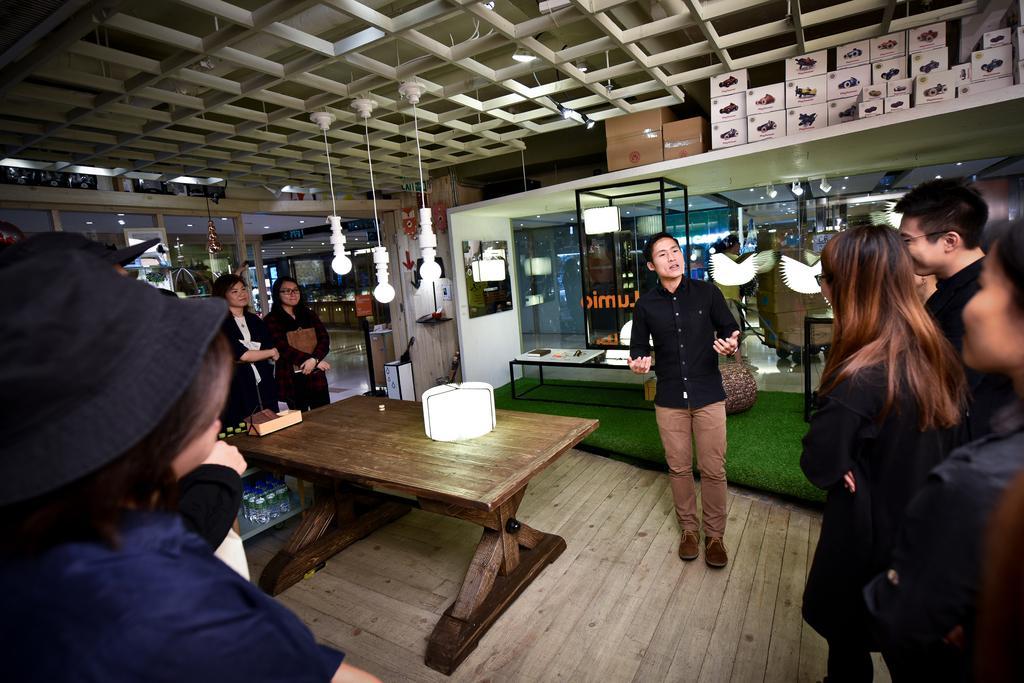In one or two sentences, can you explain what this image depicts? In this image I can see the group of people standing. And these people are wearing the different color dresses. I can see the white color object on the table. In the back I can see few more tables, the glass wall and also a board to the wall. I can see some cardboard boxes in the top. And I can also see some lights in the top. 